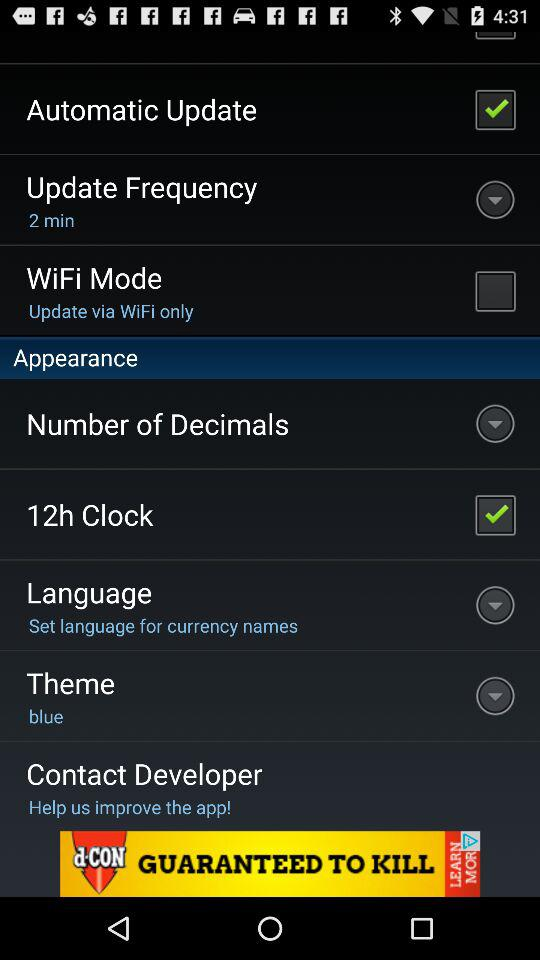What is the selected update frequency? The selected update frequency is 2 minute. 